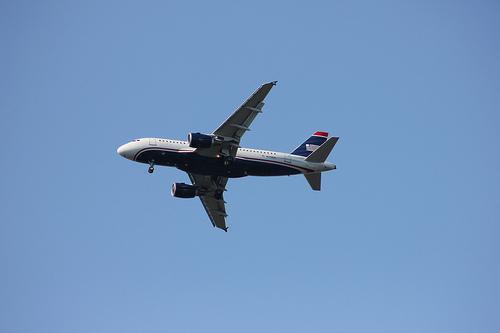How many planes are there?
Give a very brief answer. 1. 